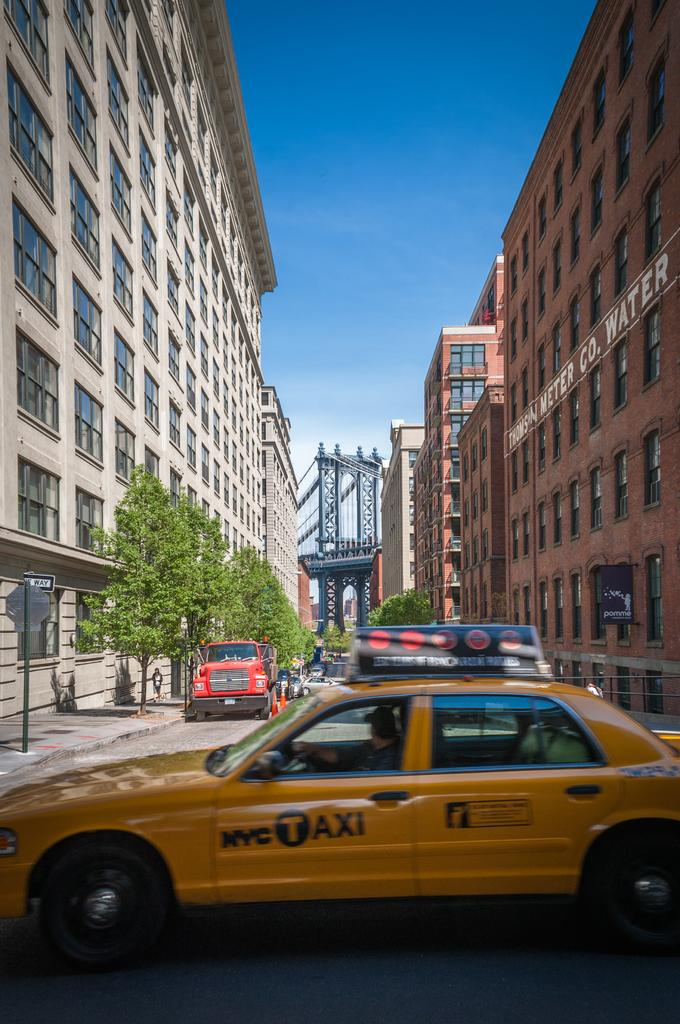<image>
Summarize the visual content of the image. A taxi with the NYC Taxi logo drives by a street with a bridge in the background. 